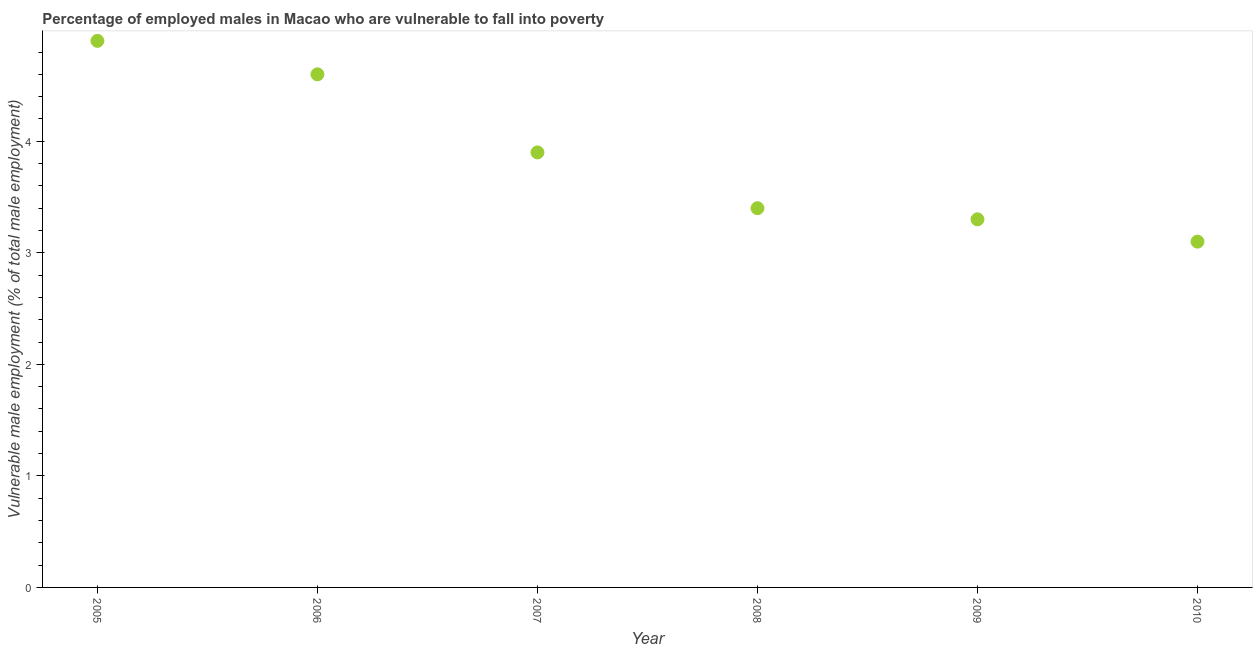What is the percentage of employed males who are vulnerable to fall into poverty in 2006?
Keep it short and to the point. 4.6. Across all years, what is the maximum percentage of employed males who are vulnerable to fall into poverty?
Offer a very short reply. 4.9. Across all years, what is the minimum percentage of employed males who are vulnerable to fall into poverty?
Your answer should be compact. 3.1. In which year was the percentage of employed males who are vulnerable to fall into poverty minimum?
Make the answer very short. 2010. What is the sum of the percentage of employed males who are vulnerable to fall into poverty?
Make the answer very short. 23.2. What is the difference between the percentage of employed males who are vulnerable to fall into poverty in 2009 and 2010?
Ensure brevity in your answer.  0.2. What is the average percentage of employed males who are vulnerable to fall into poverty per year?
Offer a terse response. 3.87. What is the median percentage of employed males who are vulnerable to fall into poverty?
Your answer should be compact. 3.65. Do a majority of the years between 2007 and 2008 (inclusive) have percentage of employed males who are vulnerable to fall into poverty greater than 0.4 %?
Keep it short and to the point. Yes. What is the ratio of the percentage of employed males who are vulnerable to fall into poverty in 2008 to that in 2009?
Provide a short and direct response. 1.03. Is the percentage of employed males who are vulnerable to fall into poverty in 2007 less than that in 2009?
Your response must be concise. No. What is the difference between the highest and the second highest percentage of employed males who are vulnerable to fall into poverty?
Make the answer very short. 0.3. What is the difference between the highest and the lowest percentage of employed males who are vulnerable to fall into poverty?
Keep it short and to the point. 1.8. In how many years, is the percentage of employed males who are vulnerable to fall into poverty greater than the average percentage of employed males who are vulnerable to fall into poverty taken over all years?
Your response must be concise. 3. How many dotlines are there?
Keep it short and to the point. 1. How many years are there in the graph?
Provide a succinct answer. 6. Does the graph contain any zero values?
Offer a terse response. No. Does the graph contain grids?
Make the answer very short. No. What is the title of the graph?
Make the answer very short. Percentage of employed males in Macao who are vulnerable to fall into poverty. What is the label or title of the X-axis?
Ensure brevity in your answer.  Year. What is the label or title of the Y-axis?
Give a very brief answer. Vulnerable male employment (% of total male employment). What is the Vulnerable male employment (% of total male employment) in 2005?
Offer a very short reply. 4.9. What is the Vulnerable male employment (% of total male employment) in 2006?
Keep it short and to the point. 4.6. What is the Vulnerable male employment (% of total male employment) in 2007?
Offer a very short reply. 3.9. What is the Vulnerable male employment (% of total male employment) in 2008?
Give a very brief answer. 3.4. What is the Vulnerable male employment (% of total male employment) in 2009?
Make the answer very short. 3.3. What is the Vulnerable male employment (% of total male employment) in 2010?
Your answer should be very brief. 3.1. What is the difference between the Vulnerable male employment (% of total male employment) in 2005 and 2007?
Your response must be concise. 1. What is the difference between the Vulnerable male employment (% of total male employment) in 2006 and 2007?
Provide a short and direct response. 0.7. What is the difference between the Vulnerable male employment (% of total male employment) in 2006 and 2008?
Offer a very short reply. 1.2. What is the difference between the Vulnerable male employment (% of total male employment) in 2007 and 2008?
Offer a very short reply. 0.5. What is the difference between the Vulnerable male employment (% of total male employment) in 2007 and 2009?
Provide a short and direct response. 0.6. What is the difference between the Vulnerable male employment (% of total male employment) in 2007 and 2010?
Provide a succinct answer. 0.8. What is the difference between the Vulnerable male employment (% of total male employment) in 2008 and 2009?
Offer a very short reply. 0.1. What is the difference between the Vulnerable male employment (% of total male employment) in 2009 and 2010?
Offer a very short reply. 0.2. What is the ratio of the Vulnerable male employment (% of total male employment) in 2005 to that in 2006?
Your response must be concise. 1.06. What is the ratio of the Vulnerable male employment (% of total male employment) in 2005 to that in 2007?
Your answer should be very brief. 1.26. What is the ratio of the Vulnerable male employment (% of total male employment) in 2005 to that in 2008?
Offer a terse response. 1.44. What is the ratio of the Vulnerable male employment (% of total male employment) in 2005 to that in 2009?
Your answer should be compact. 1.49. What is the ratio of the Vulnerable male employment (% of total male employment) in 2005 to that in 2010?
Offer a terse response. 1.58. What is the ratio of the Vulnerable male employment (% of total male employment) in 2006 to that in 2007?
Your answer should be very brief. 1.18. What is the ratio of the Vulnerable male employment (% of total male employment) in 2006 to that in 2008?
Keep it short and to the point. 1.35. What is the ratio of the Vulnerable male employment (% of total male employment) in 2006 to that in 2009?
Ensure brevity in your answer.  1.39. What is the ratio of the Vulnerable male employment (% of total male employment) in 2006 to that in 2010?
Provide a succinct answer. 1.48. What is the ratio of the Vulnerable male employment (% of total male employment) in 2007 to that in 2008?
Your answer should be very brief. 1.15. What is the ratio of the Vulnerable male employment (% of total male employment) in 2007 to that in 2009?
Your answer should be very brief. 1.18. What is the ratio of the Vulnerable male employment (% of total male employment) in 2007 to that in 2010?
Ensure brevity in your answer.  1.26. What is the ratio of the Vulnerable male employment (% of total male employment) in 2008 to that in 2010?
Offer a very short reply. 1.1. What is the ratio of the Vulnerable male employment (% of total male employment) in 2009 to that in 2010?
Your response must be concise. 1.06. 